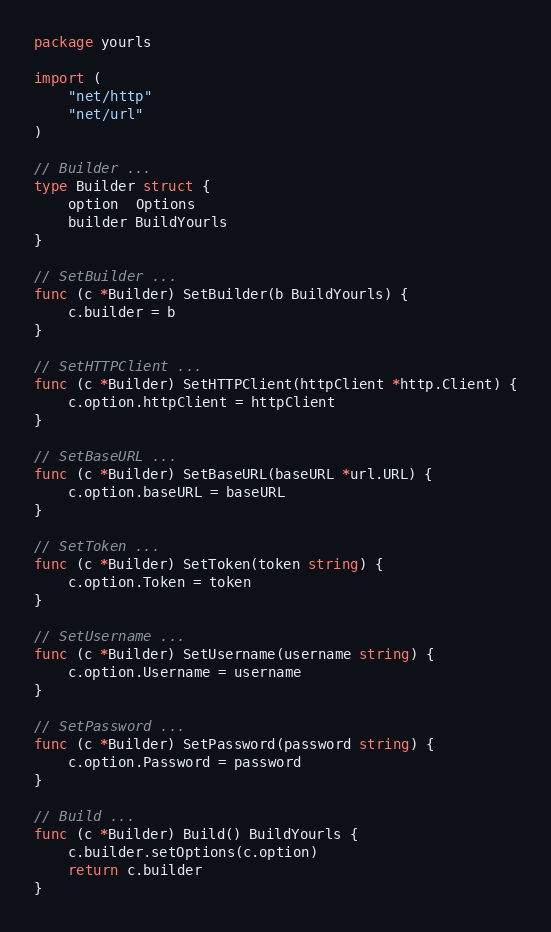Convert code to text. <code><loc_0><loc_0><loc_500><loc_500><_Go_>package yourls

import (
	"net/http"
	"net/url"
)

// Builder ...
type Builder struct {
	option  Options
	builder BuildYourls
}

// SetBuilder ...
func (c *Builder) SetBuilder(b BuildYourls) {
	c.builder = b
}

// SetHTTPClient ...
func (c *Builder) SetHTTPClient(httpClient *http.Client) {
	c.option.httpClient = httpClient
}

// SetBaseURL ...
func (c *Builder) SetBaseURL(baseURL *url.URL) {
	c.option.baseURL = baseURL
}

// SetToken ...
func (c *Builder) SetToken(token string) {
	c.option.Token = token
}

// SetUsername ...
func (c *Builder) SetUsername(username string) {
	c.option.Username = username
}

// SetPassword ...
func (c *Builder) SetPassword(password string) {
	c.option.Password = password
}

// Build ...
func (c *Builder) Build() BuildYourls {
	c.builder.setOptions(c.option)
	return c.builder
}
</code> 